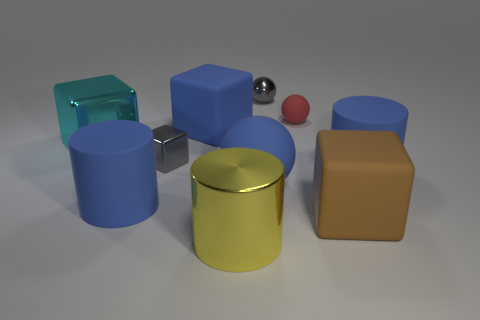There is a sphere that is the same color as the small shiny cube; what is its size?
Keep it short and to the point. Small. Is the large cylinder that is to the right of the big rubber sphere made of the same material as the large cyan thing?
Offer a terse response. No. There is a cylinder that is on the right side of the big metal thing that is to the right of the large blue cylinder left of the yellow shiny thing; what size is it?
Keep it short and to the point. Large. The metal thing that is the same shape as the tiny rubber object is what color?
Give a very brief answer. Gray. Is the yellow shiny cylinder the same size as the blue matte sphere?
Provide a short and direct response. Yes. There is a small thing that is in front of the large blue block; what is its material?
Provide a succinct answer. Metal. How many other objects are the same shape as the yellow metal thing?
Your answer should be very brief. 2. Is the shape of the large cyan metallic object the same as the small red rubber object?
Give a very brief answer. No. Are there any blue cylinders behind the big ball?
Ensure brevity in your answer.  Yes. What number of objects are either tiny purple matte cylinders or large rubber blocks?
Keep it short and to the point. 2. 